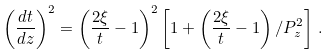Convert formula to latex. <formula><loc_0><loc_0><loc_500><loc_500>\left ( \frac { d t } { d z } \right ) ^ { 2 } = \left ( \frac { 2 \xi } { t } - 1 \right ) ^ { 2 } \left [ 1 + \left ( \frac { 2 \xi } { t } - 1 \right ) / P _ { z } ^ { 2 } \right ] \, .</formula> 